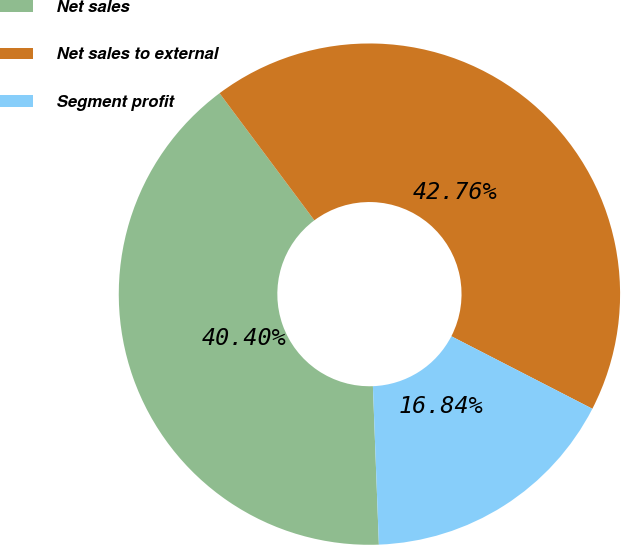<chart> <loc_0><loc_0><loc_500><loc_500><pie_chart><fcel>Net sales<fcel>Net sales to external<fcel>Segment profit<nl><fcel>40.4%<fcel>42.76%<fcel>16.84%<nl></chart> 